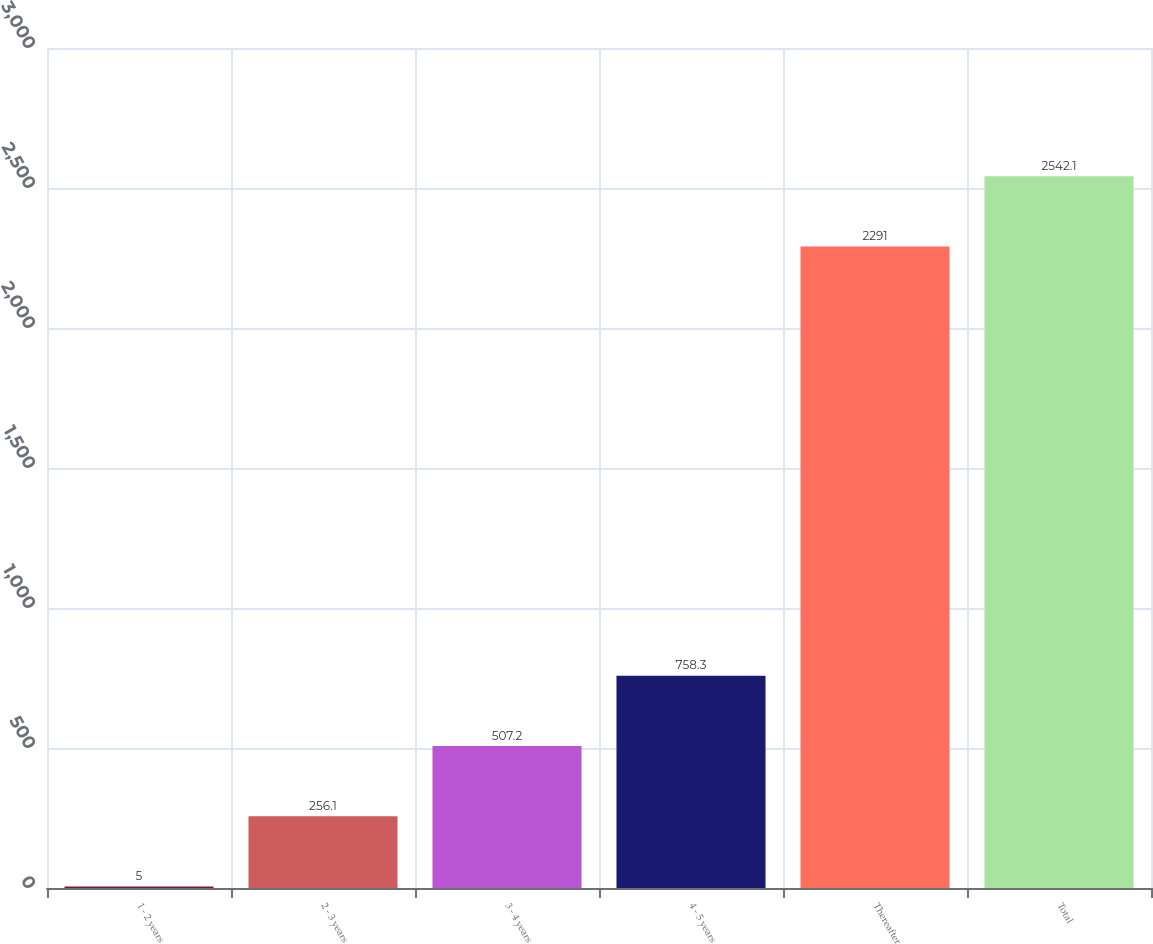Convert chart. <chart><loc_0><loc_0><loc_500><loc_500><bar_chart><fcel>1 - 2 years<fcel>2 - 3 years<fcel>3 - 4 years<fcel>4 - 5 years<fcel>Thereafter<fcel>Total<nl><fcel>5<fcel>256.1<fcel>507.2<fcel>758.3<fcel>2291<fcel>2542.1<nl></chart> 